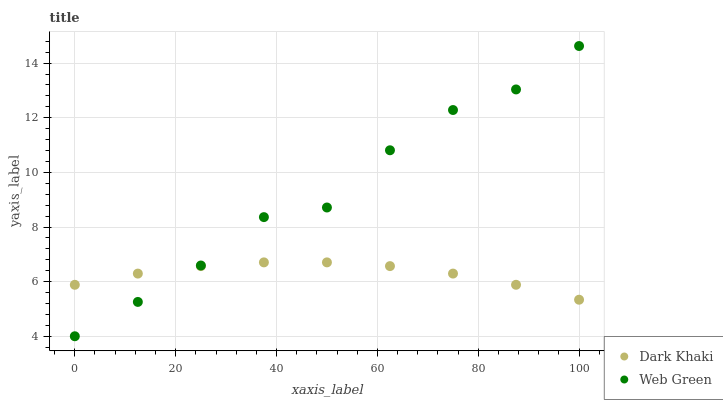Does Dark Khaki have the minimum area under the curve?
Answer yes or no. Yes. Does Web Green have the maximum area under the curve?
Answer yes or no. Yes. Does Web Green have the minimum area under the curve?
Answer yes or no. No. Is Dark Khaki the smoothest?
Answer yes or no. Yes. Is Web Green the roughest?
Answer yes or no. Yes. Is Web Green the smoothest?
Answer yes or no. No. Does Web Green have the lowest value?
Answer yes or no. Yes. Does Web Green have the highest value?
Answer yes or no. Yes. Does Dark Khaki intersect Web Green?
Answer yes or no. Yes. Is Dark Khaki less than Web Green?
Answer yes or no. No. Is Dark Khaki greater than Web Green?
Answer yes or no. No. 